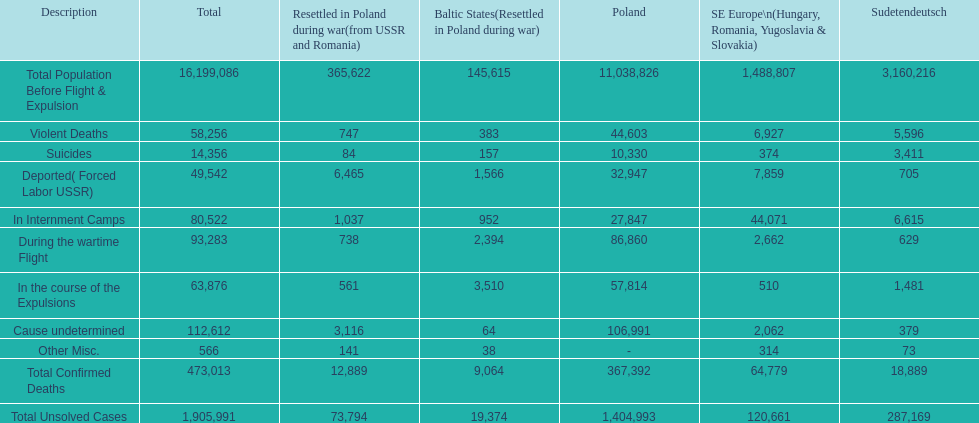How many causes were responsible for more than 50,000 confirmed deaths? 5. 